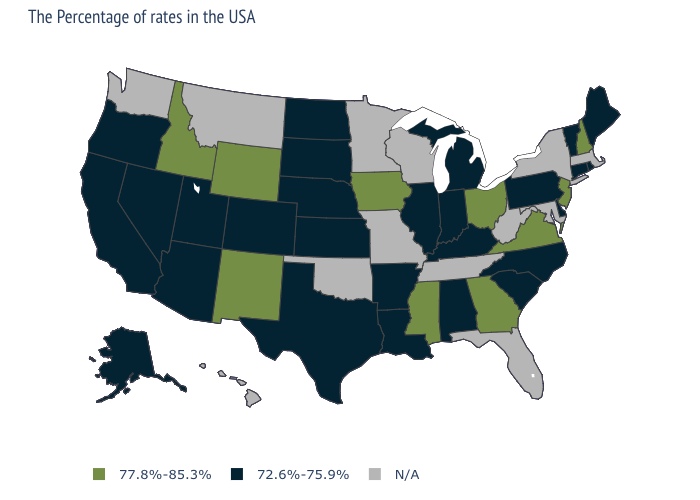What is the value of Kansas?
Write a very short answer. 72.6%-75.9%. What is the highest value in the USA?
Keep it brief. 77.8%-85.3%. What is the highest value in states that border Vermont?
Concise answer only. 77.8%-85.3%. What is the value of Arkansas?
Quick response, please. 72.6%-75.9%. Does Kansas have the lowest value in the MidWest?
Short answer required. Yes. What is the lowest value in the MidWest?
Short answer required. 72.6%-75.9%. Name the states that have a value in the range 72.6%-75.9%?
Be succinct. Maine, Rhode Island, Vermont, Connecticut, Delaware, Pennsylvania, North Carolina, South Carolina, Michigan, Kentucky, Indiana, Alabama, Illinois, Louisiana, Arkansas, Kansas, Nebraska, Texas, South Dakota, North Dakota, Colorado, Utah, Arizona, Nevada, California, Oregon, Alaska. Name the states that have a value in the range 77.8%-85.3%?
Give a very brief answer. New Hampshire, New Jersey, Virginia, Ohio, Georgia, Mississippi, Iowa, Wyoming, New Mexico, Idaho. What is the value of Massachusetts?
Answer briefly. N/A. Which states have the lowest value in the South?
Keep it brief. Delaware, North Carolina, South Carolina, Kentucky, Alabama, Louisiana, Arkansas, Texas. What is the value of Maine?
Short answer required. 72.6%-75.9%. Which states have the lowest value in the West?
Write a very short answer. Colorado, Utah, Arizona, Nevada, California, Oregon, Alaska. 